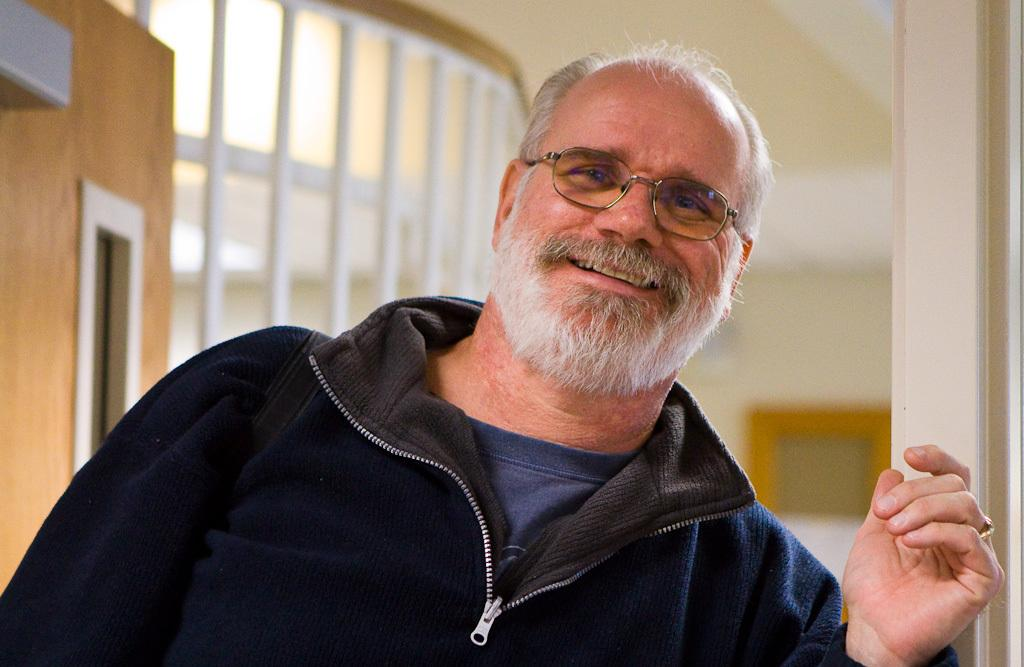What type of view is shown in the image? The image shows the inner view of a building. Can you describe the person in the image? There is a man sitting near the door in the image. What can be seen on the surfaces in the image? There are objects on the surface in the image. What type of baseball appliance is being used in the image? There is no baseball appliance present in the image. Can you describe the air quality in the image? The provided facts do not give us any information about the air quality in the image. 